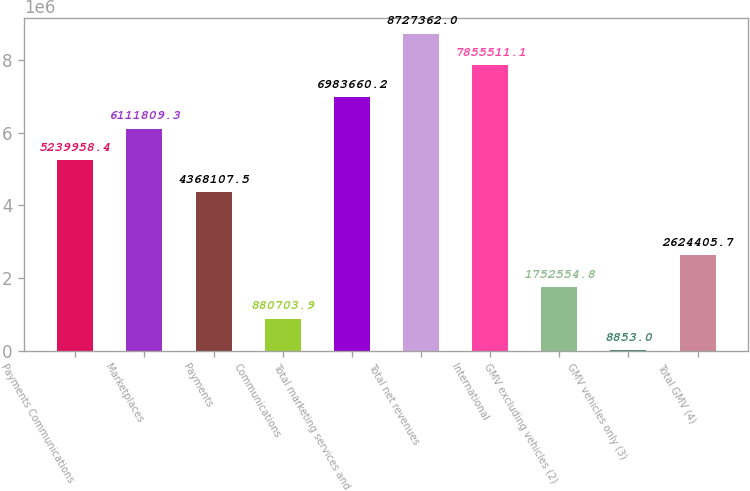<chart> <loc_0><loc_0><loc_500><loc_500><bar_chart><fcel>Payments Communications<fcel>Marketplaces<fcel>Payments<fcel>Communications<fcel>Total marketing services and<fcel>Total net revenues<fcel>International<fcel>GMV excluding vehicles (2)<fcel>GMV vehicles only (3)<fcel>Total GMV (4)<nl><fcel>5.23996e+06<fcel>6.11181e+06<fcel>4.36811e+06<fcel>880704<fcel>6.98366e+06<fcel>8.72736e+06<fcel>7.85551e+06<fcel>1.75255e+06<fcel>8853<fcel>2.62441e+06<nl></chart> 